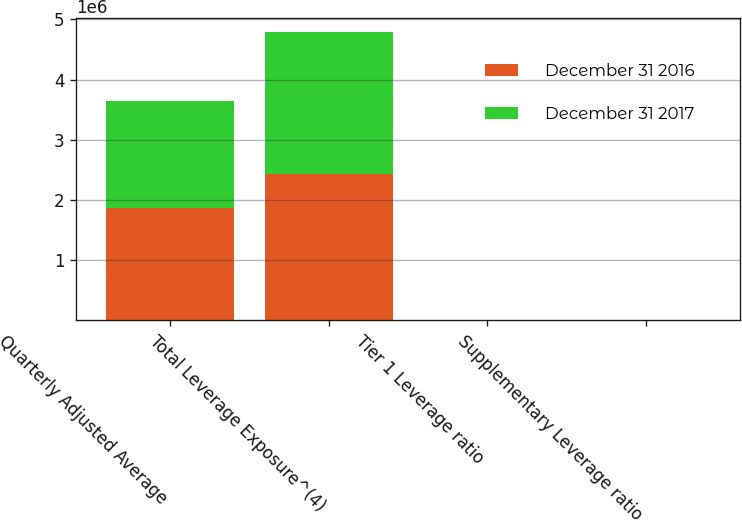Convert chart to OTSL. <chart><loc_0><loc_0><loc_500><loc_500><stacked_bar_chart><ecel><fcel>Quarterly Adjusted Average<fcel>Total Leverage Exposure^(4)<fcel>Tier 1 Leverage ratio<fcel>Supplementary Leverage ratio<nl><fcel>December 31 2016<fcel>1.86921e+06<fcel>2.43337e+06<fcel>8.82<fcel>6.77<nl><fcel>December 31 2017<fcel>1.76842e+06<fcel>2.35188e+06<fcel>10.09<fcel>7.58<nl></chart> 